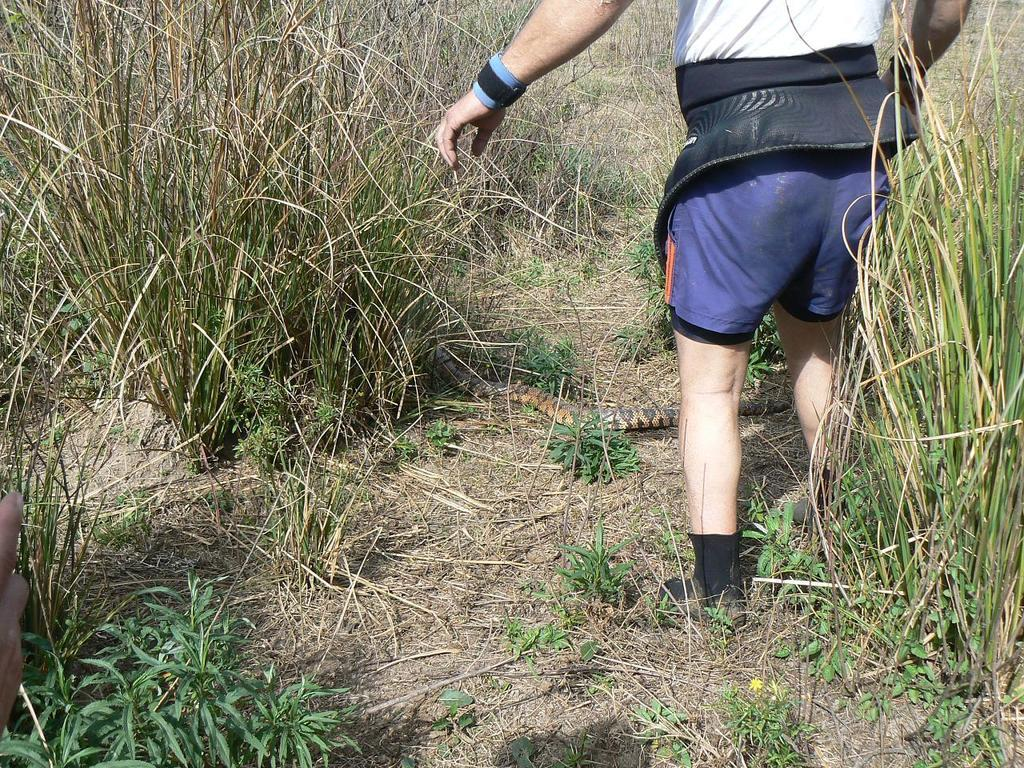Who is present in the image? There is a man in the image. Where is the man located in the image? The man is on the right side of the image. What type of environment is visible in the image? There is grassland surrounding the area in the image. What type of watch is the man wearing in the image? There is no watch visible on the man in the image. How many elbows does the man have in the image? The man has two elbows in the image, but this question is absurd as the number of elbows a person has is a constant and not dependent on the image. 